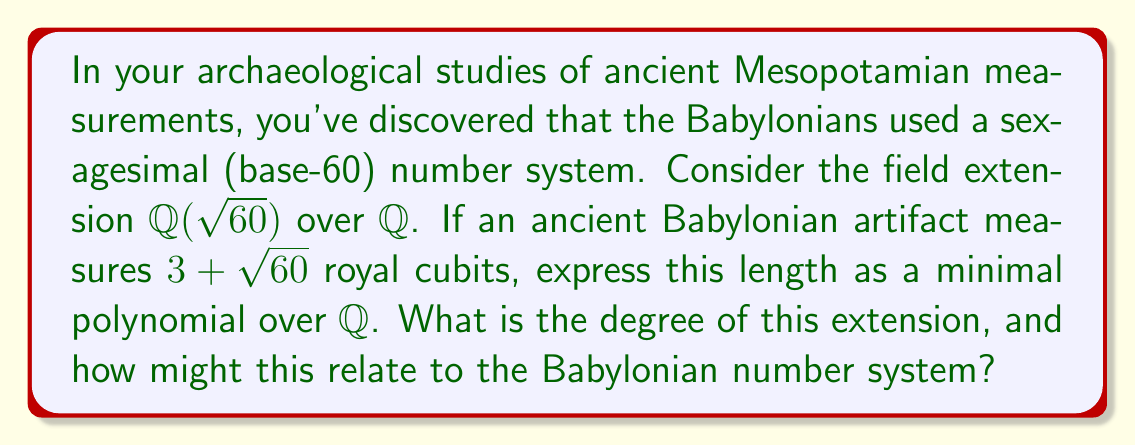Can you answer this question? Let's approach this step-by-step:

1) The length $3 + \sqrt{60}$ is an element of the field extension $\mathbb{Q}(\sqrt{60})$.

2) To find the minimal polynomial, let $x = 3 + \sqrt{60}$. We need to isolate $\sqrt{60}$:

   $x - 3 = \sqrt{60}$

3) Square both sides:

   $(x - 3)^2 = 60$

4) Expand:

   $x^2 - 6x + 9 = 60$

5) Rearrange to standard form:

   $x^2 - 6x - 51 = 0$

This is the minimal polynomial for $3 + \sqrt{60}$ over $\mathbb{Q}$.

6) The degree of this polynomial is 2, which is also the degree of the field extension $[\mathbb{Q}(\sqrt{60}):\mathbb{Q}]$.

7) Relation to Babylonian number system:
   - The base of the Babylonian system, 60, appears in the extension $\mathbb{Q}(\sqrt{60})$.
   - The degree 2 relates to the quadratic nature of $\sqrt{60}$.
   - The Babylonians were adept at solving quadratic equations, which aligns with this quadratic extension.
   - The minimal polynomial coefficients (-6 and -51) are easily expressible in base 60.

This connection between the field extension and the Babylonian number system showcases how modern abstract algebra can model and provide insights into ancient mathematical practices.
Answer: The minimal polynomial is $x^2 - 6x - 51 = 0$. The degree of the extension $[\mathbb{Q}(\sqrt{60}):\mathbb{Q}]$ is 2. 